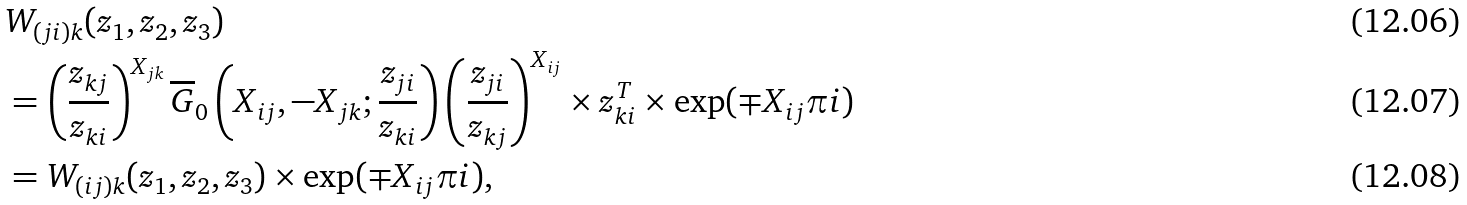<formula> <loc_0><loc_0><loc_500><loc_500>& W _ { ( j i ) k } ( z _ { 1 } , z _ { 2 } , z _ { 3 } ) \\ & = \left ( \frac { z _ { k j } } { z _ { k i } } \right ) ^ { X _ { j k } } \overline { G } _ { 0 } \left ( X _ { i j } , - X _ { j k } ; \frac { z _ { j i } } { z _ { k i } } \right ) \left ( \frac { z _ { j i } } { z _ { k j } } \right ) ^ { X _ { i j } } \times z _ { k i } ^ { T } \times \exp ( \mp X _ { i j } \pi i ) \\ & = W _ { ( i j ) k } ( z _ { 1 } , z _ { 2 } , z _ { 3 } ) \times \exp ( \mp X _ { i j } \pi i ) ,</formula> 